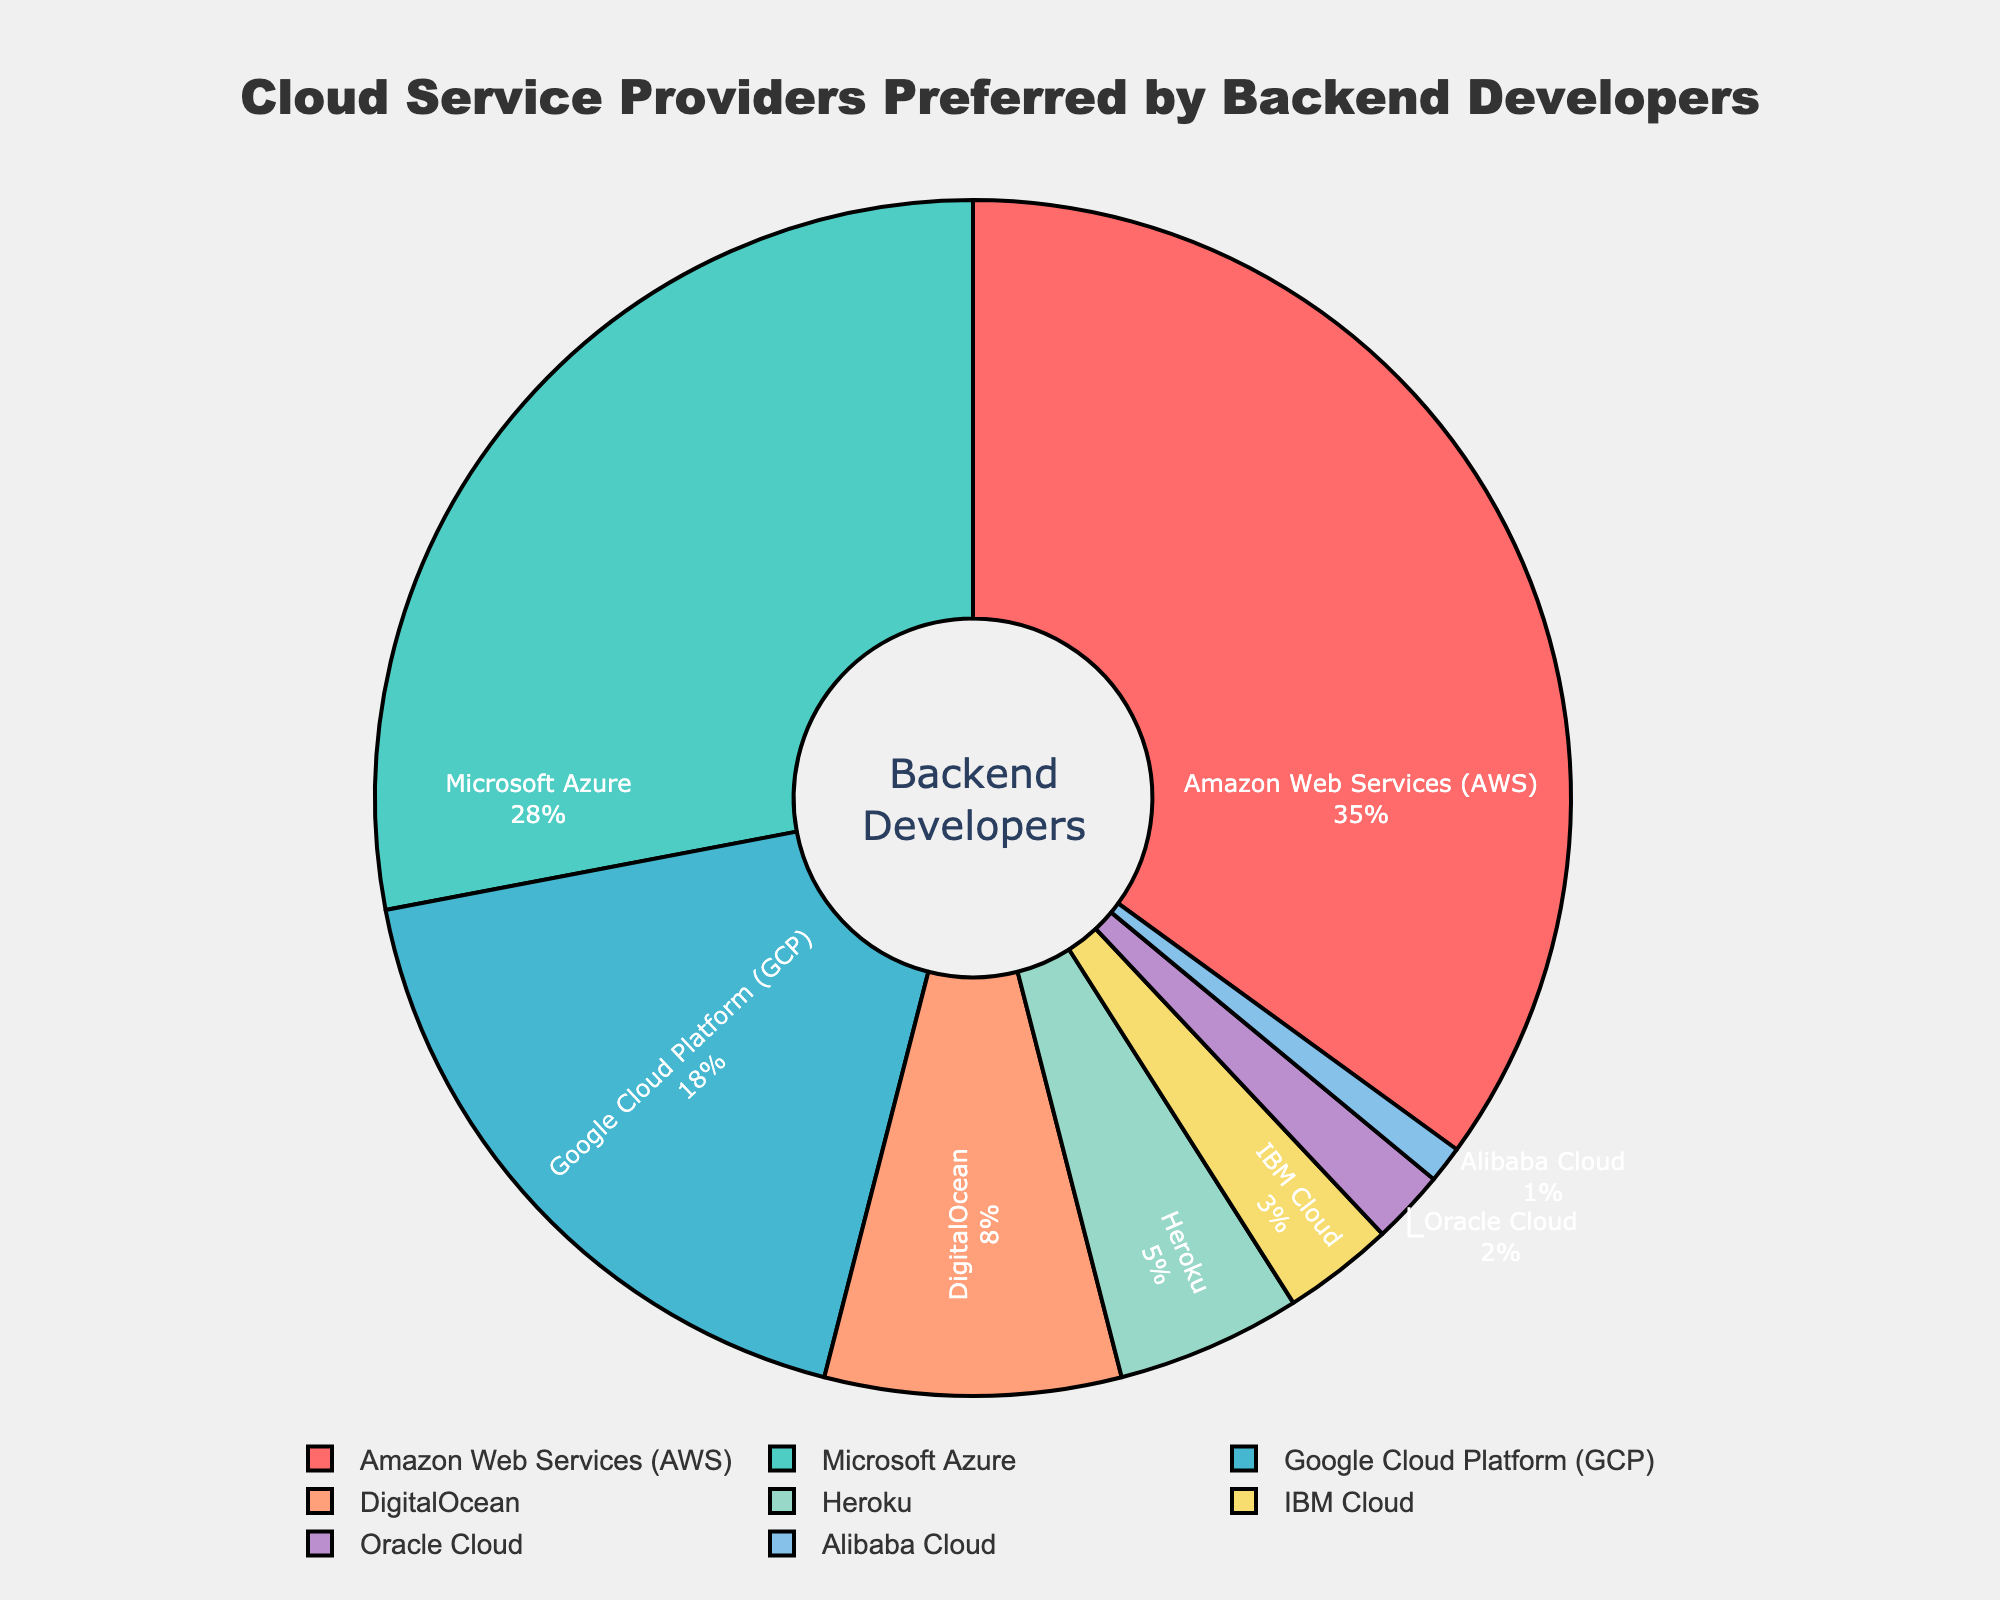Which cloud service provider is preferred the most by backend developers? The figure shows a pie chart with the largest segment labeled "Amazon Web Services (AWS)" with a 35% share.
Answer: AWS What percentage of backend developers prefer Microsoft Azure? The label on the pie chart indicates that "Microsoft Azure" has a 28% share.
Answer: 28% How many cloud service providers have a preference of less than 5%? From the pie chart, the segments labeled "Heroku," "IBM Cloud," "Oracle Cloud," and "Alibaba Cloud" each have percentages of 5%, 3%, 2%, and 1%, respectively. Hence, four providers have less than 5%.
Answer: 4 Do more backend developers prefer Google Cloud Platform (GCP) or DigitalOcean? The pie chart shows 18% for "Google Cloud Platform (GCP)" and 8% for "DigitalOcean." Thus, more developers prefer GCP.
Answer: GCP What is the combined preference percentage for IBM Cloud and Oracle Cloud? The pie chart segments for "IBM Cloud" and "Oracle Cloud" show 3% and 2%, respectively. Summing these values (3% + 2%) gives the combined preference percentage.
Answer: 5% How much higher is the preference for AWS compared to Heroku? AWS has a 35% share, while Heroku has a 5% share. The difference is 35% - 5%.
Answer: 30% Which cloud service provider is represented by the green segment? Upon visually inspecting the chart’s colors, the green segment is labeled "Microsoft Azure."
Answer: Microsoft Azure Rank the top three cloud service providers by preference percentage. According to the pie chart, the top three providers are "Amazon Web Services (AWS)" with 35%, "Microsoft Azure" with 28%, and "Google Cloud Platform (GCP)" with 18%.
Answer: 1. AWS, 2. Microsoft Azure, 3. GCP 